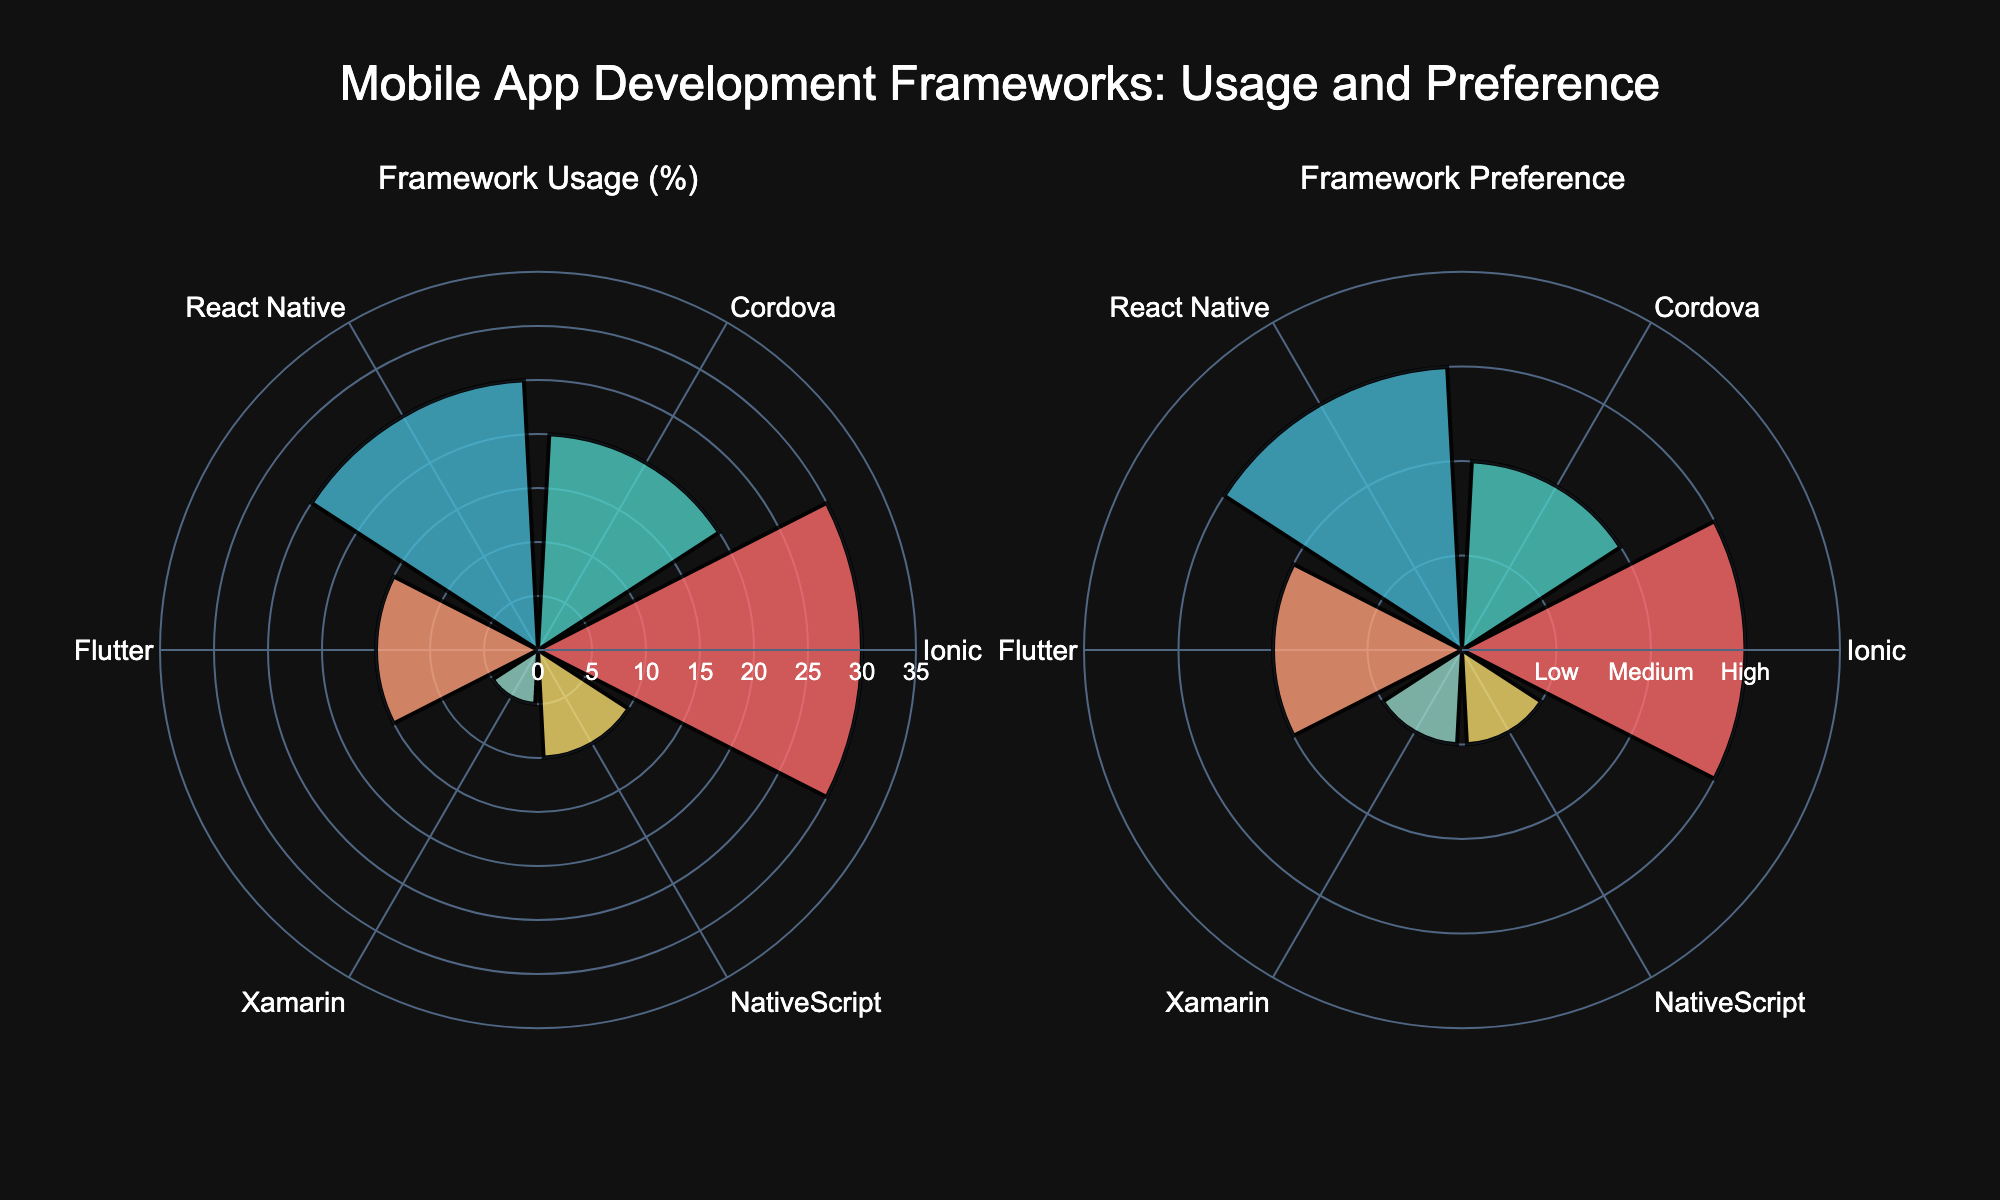What is the title of the figure? The title is usually placed at the top center of the figure. Here, it clearly states, "Mobile App Development Frameworks: Usage and Preference".
Answer: Mobile App Development Frameworks: Usage and Preference Which framework has the highest usage percentage? By looking at the heights of the bars in the first polar chart, Ionic has the highest usage percentage.
Answer: Ionic How does the preference for React Native compare to NativeScript? The second polar chart displays preference values numerically. React Native has a 'High' preference value (3), while NativeScript has a 'Low' preference value (1). Thus, React Native is preferred more than NativeScript.
Answer: React Native is preferred more What are the usage percentages for Cordova and Flutter, and what is the difference? The heights of the bars in the first polar chart show that Cordova has a usage percentage of 20% and Flutter has 15%. The difference is 20% - 15% = 5%.
Answer: 5% Which frameworks have a medium preference level? The second polar chart’s radial axis labels show which bars fall under the 'Medium' preference value. Both Cordova and Flutter fall into this category.
Answer: Cordova and Flutter Which framework has the lowest preference and usage? By examining the shortest bars in both polar charts, Xamarin has the lowest in both preference and usage categories.
Answer: Xamarin Compare the usage percentage of Ionic and Flutter. Which framework is used more? In the first polar chart, Ionic has a usage percentage of 30%, while Flutter has 15%, making Ionic used more compared to Flutter.
Answer: Ionic What is the sum of usage percentages for React Native and Xamarin? By adding the usage percentages from the first polar chart: React Native (25%) + Xamarin (5%) = 30%.
Answer: 30% Which framework has an equal usage value to NativeScript's preference value? NativeScript has a 'Low' preference value of 1 on the second polar chart. Looking at the first polar chart, no framework has a usage percentage of 1%, meaning there is no matching value.
Answer: None Based on the data, which framework could you say is both popular and highly preferred? The first polar chart shows Ionic with the highest usage, and the second polar chart shows it with a 'High' preference value. Thus, Ionic is both popular and highly preferred.
Answer: Ionic 